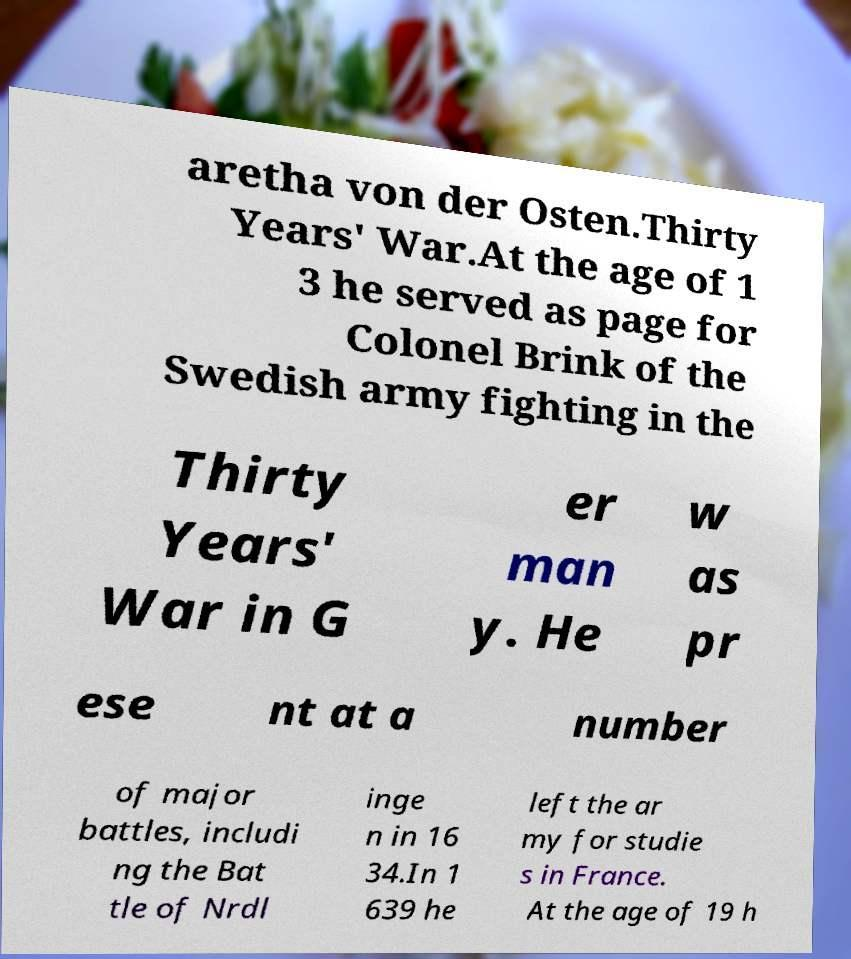Please identify and transcribe the text found in this image. aretha von der Osten.Thirty Years' War.At the age of 1 3 he served as page for Colonel Brink of the Swedish army fighting in the Thirty Years' War in G er man y. He w as pr ese nt at a number of major battles, includi ng the Bat tle of Nrdl inge n in 16 34.In 1 639 he left the ar my for studie s in France. At the age of 19 h 